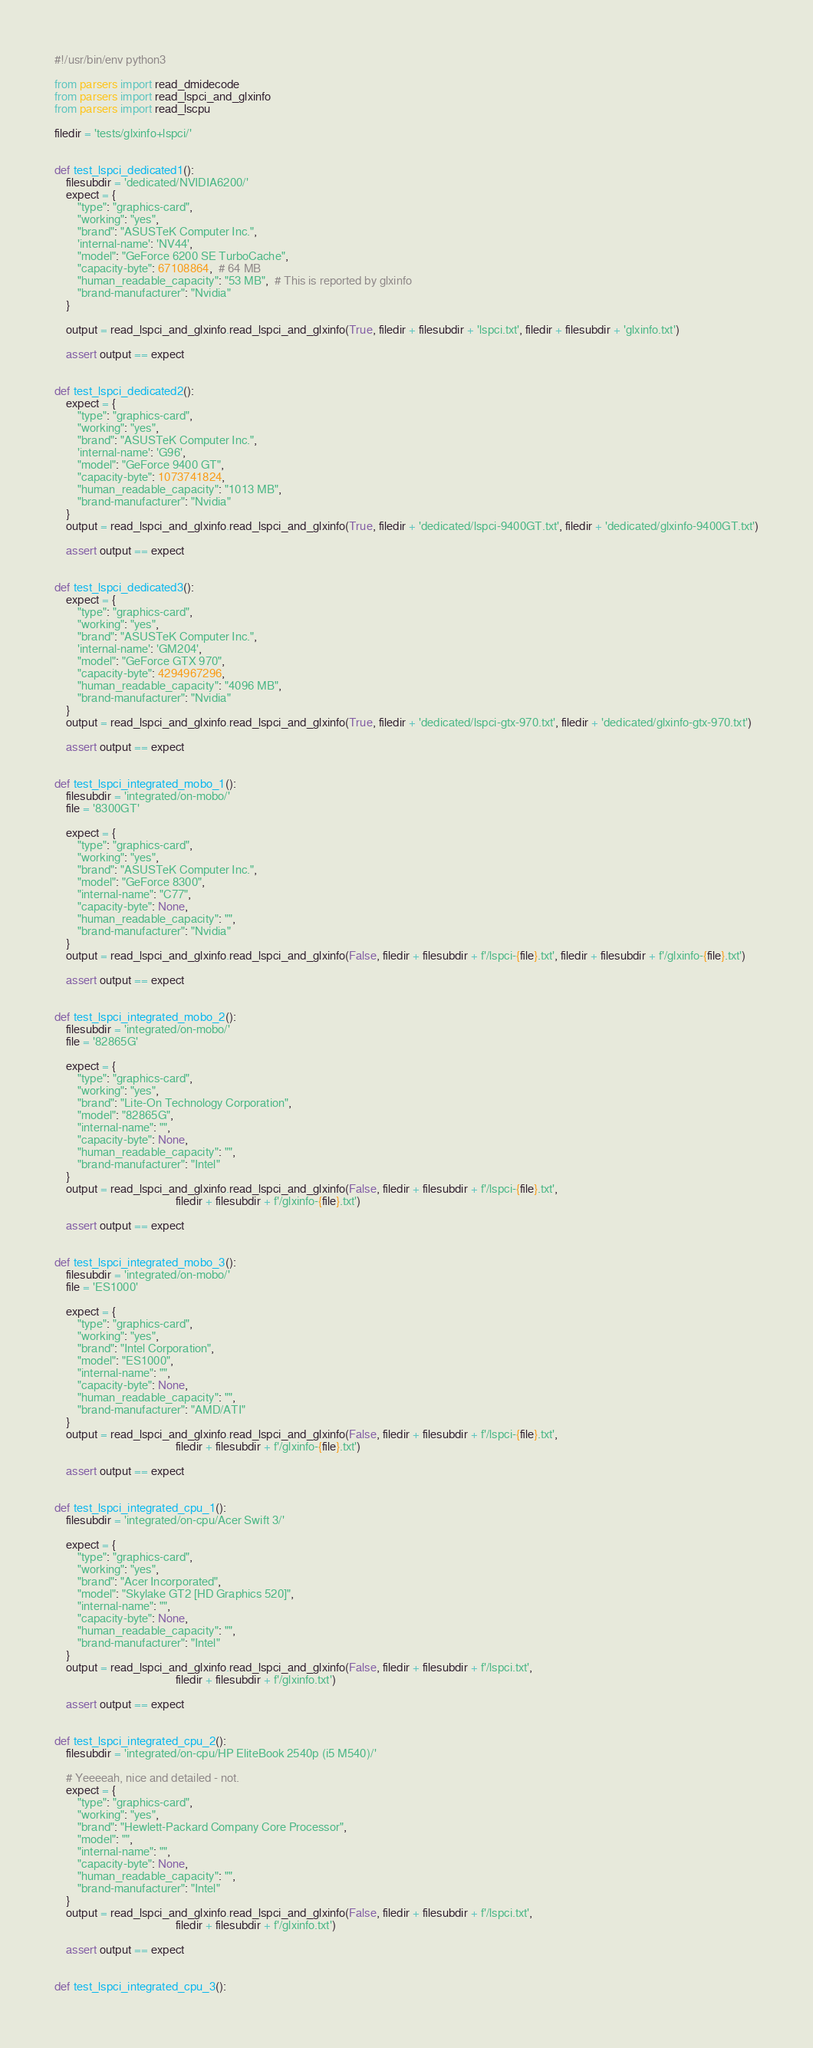<code> <loc_0><loc_0><loc_500><loc_500><_Python_>#!/usr/bin/env python3

from parsers import read_dmidecode
from parsers import read_lspci_and_glxinfo
from parsers import read_lscpu

filedir = 'tests/glxinfo+lspci/'


def test_lspci_dedicated1():
	filesubdir = 'dedicated/NVIDIA6200/'
	expect = {
		"type": "graphics-card",
		"working": "yes",
		"brand": "ASUSTeK Computer Inc.",
		'internal-name': 'NV44',
		"model": "GeForce 6200 SE TurboCache",
		"capacity-byte": 67108864,  # 64 MB
		"human_readable_capacity": "53 MB",  # This is reported by glxinfo
		"brand-manufacturer": "Nvidia"
	}

	output = read_lspci_and_glxinfo.read_lspci_and_glxinfo(True, filedir + filesubdir + 'lspci.txt', filedir + filesubdir + 'glxinfo.txt')

	assert output == expect


def test_lspci_dedicated2():
	expect = {
		"type": "graphics-card",
		"working": "yes",
		"brand": "ASUSTeK Computer Inc.",
		'internal-name': 'G96',
		"model": "GeForce 9400 GT",
		"capacity-byte": 1073741824,
		"human_readable_capacity": "1013 MB",
		"brand-manufacturer": "Nvidia"
	}
	output = read_lspci_and_glxinfo.read_lspci_and_glxinfo(True, filedir + 'dedicated/lspci-9400GT.txt', filedir + 'dedicated/glxinfo-9400GT.txt')

	assert output == expect


def test_lspci_dedicated3():
	expect = {
		"type": "graphics-card",
		"working": "yes",
		"brand": "ASUSTeK Computer Inc.",
		'internal-name': 'GM204',
		"model": "GeForce GTX 970",
		"capacity-byte": 4294967296,
		"human_readable_capacity": "4096 MB",
		"brand-manufacturer": "Nvidia"
	}
	output = read_lspci_and_glxinfo.read_lspci_and_glxinfo(True, filedir + 'dedicated/lspci-gtx-970.txt', filedir + 'dedicated/glxinfo-gtx-970.txt')

	assert output == expect


def test_lspci_integrated_mobo_1():
	filesubdir = 'integrated/on-mobo/'
	file = '8300GT'

	expect = {
		"type": "graphics-card",
		"working": "yes",
		"brand": "ASUSTeK Computer Inc.",
		"model": "GeForce 8300",
		"internal-name": "C77",
		"capacity-byte": None,
		"human_readable_capacity": "",
		"brand-manufacturer": "Nvidia"
	}
	output = read_lspci_and_glxinfo.read_lspci_and_glxinfo(False, filedir + filesubdir + f'/lspci-{file}.txt', filedir + filesubdir + f'/glxinfo-{file}.txt')

	assert output == expect


def test_lspci_integrated_mobo_2():
	filesubdir = 'integrated/on-mobo/'
	file = '82865G'

	expect = {
		"type": "graphics-card",
		"working": "yes",
		"brand": "Lite-On Technology Corporation",
		"model": "82865G",
		"internal-name": "",
		"capacity-byte": None,
		"human_readable_capacity": "",
		"brand-manufacturer": "Intel"
	}
	output = read_lspci_and_glxinfo.read_lspci_and_glxinfo(False, filedir + filesubdir + f'/lspci-{file}.txt',
	                                      filedir + filesubdir + f'/glxinfo-{file}.txt')

	assert output == expect


def test_lspci_integrated_mobo_3():
	filesubdir = 'integrated/on-mobo/'
	file = 'ES1000'

	expect = {
		"type": "graphics-card",
		"working": "yes",
		"brand": "Intel Corporation",
		"model": "ES1000",
		"internal-name": "",
		"capacity-byte": None,
		"human_readable_capacity": "",
		"brand-manufacturer": "AMD/ATI"
	}
	output = read_lspci_and_glxinfo.read_lspci_and_glxinfo(False, filedir + filesubdir + f'/lspci-{file}.txt',
	                                      filedir + filesubdir + f'/glxinfo-{file}.txt')

	assert output == expect


def test_lspci_integrated_cpu_1():
	filesubdir = 'integrated/on-cpu/Acer Swift 3/'

	expect = {
		"type": "graphics-card",
		"working": "yes",
		"brand": "Acer Incorporated",
		"model": "Skylake GT2 [HD Graphics 520]",
		"internal-name": "",
		"capacity-byte": None,
		"human_readable_capacity": "",
		"brand-manufacturer": "Intel"
	}
	output = read_lspci_and_glxinfo.read_lspci_and_glxinfo(False, filedir + filesubdir + f'/lspci.txt',
	                                      filedir + filesubdir + f'/glxinfo.txt')

	assert output == expect


def test_lspci_integrated_cpu_2():
	filesubdir = 'integrated/on-cpu/HP EliteBook 2540p (i5 M540)/'

	# Yeeeeah, nice and detailed - not.
	expect = {
		"type": "graphics-card",
		"working": "yes",
		"brand": "Hewlett-Packard Company Core Processor",
		"model": "",
		"internal-name": "",
		"capacity-byte": None,
		"human_readable_capacity": "",
		"brand-manufacturer": "Intel"
	}
	output = read_lspci_and_glxinfo.read_lspci_and_glxinfo(False, filedir + filesubdir + f'/lspci.txt',
	                                      filedir + filesubdir + f'/glxinfo.txt')

	assert output == expect


def test_lspci_integrated_cpu_3():</code> 